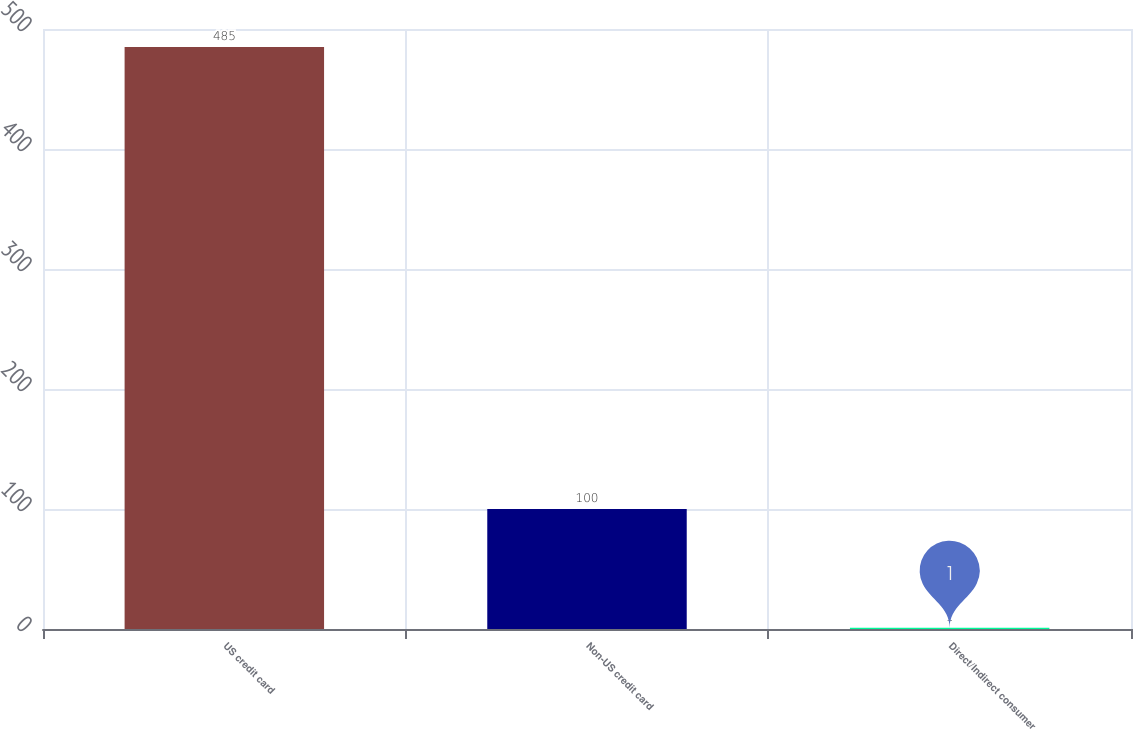<chart> <loc_0><loc_0><loc_500><loc_500><bar_chart><fcel>US credit card<fcel>Non-US credit card<fcel>Direct/Indirect consumer<nl><fcel>485<fcel>100<fcel>1<nl></chart> 